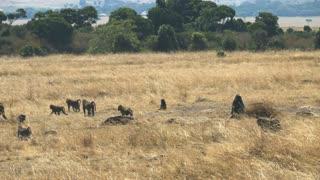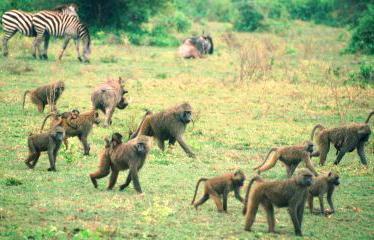The first image is the image on the left, the second image is the image on the right. Examine the images to the left and right. Is the description "Some of the animals are in a dirt path." accurate? Answer yes or no. No. The first image is the image on the left, the second image is the image on the right. Evaluate the accuracy of this statement regarding the images: "An image shows baboons sitting in a patch of dirt near a tree.". Is it true? Answer yes or no. No. 